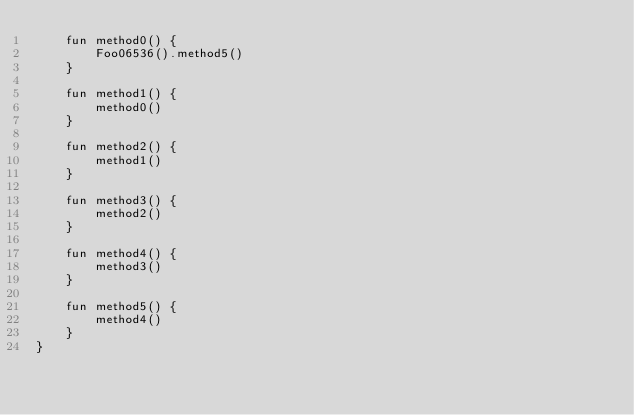Convert code to text. <code><loc_0><loc_0><loc_500><loc_500><_Kotlin_>    fun method0() {
        Foo06536().method5()
    }

    fun method1() {
        method0()
    }

    fun method2() {
        method1()
    }

    fun method3() {
        method2()
    }

    fun method4() {
        method3()
    }

    fun method5() {
        method4()
    }
}
</code> 